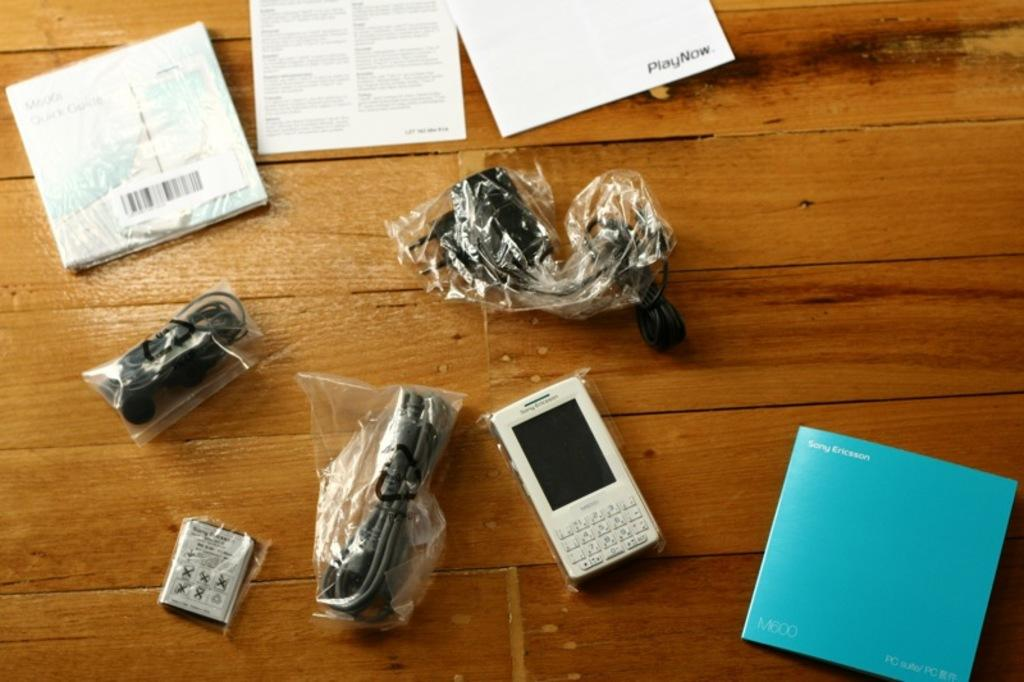<image>
Render a clear and concise summary of the photo. wooden tabletop with a white sony ericsson m600 phone, battery cables, and booklets 